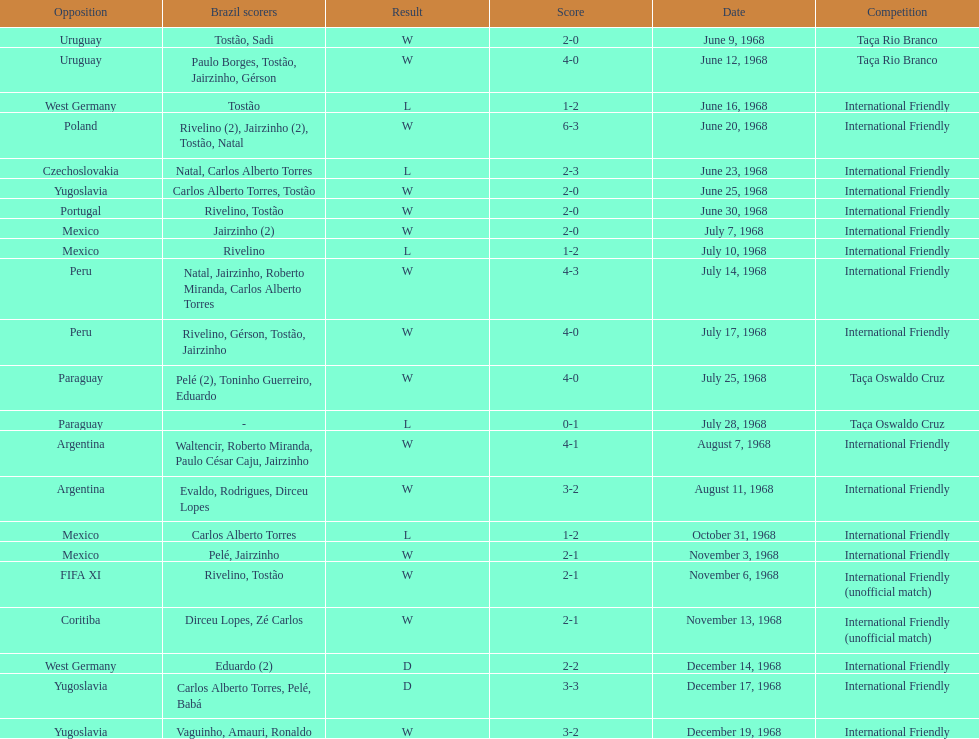What year has the highest scoring game? 1968. 